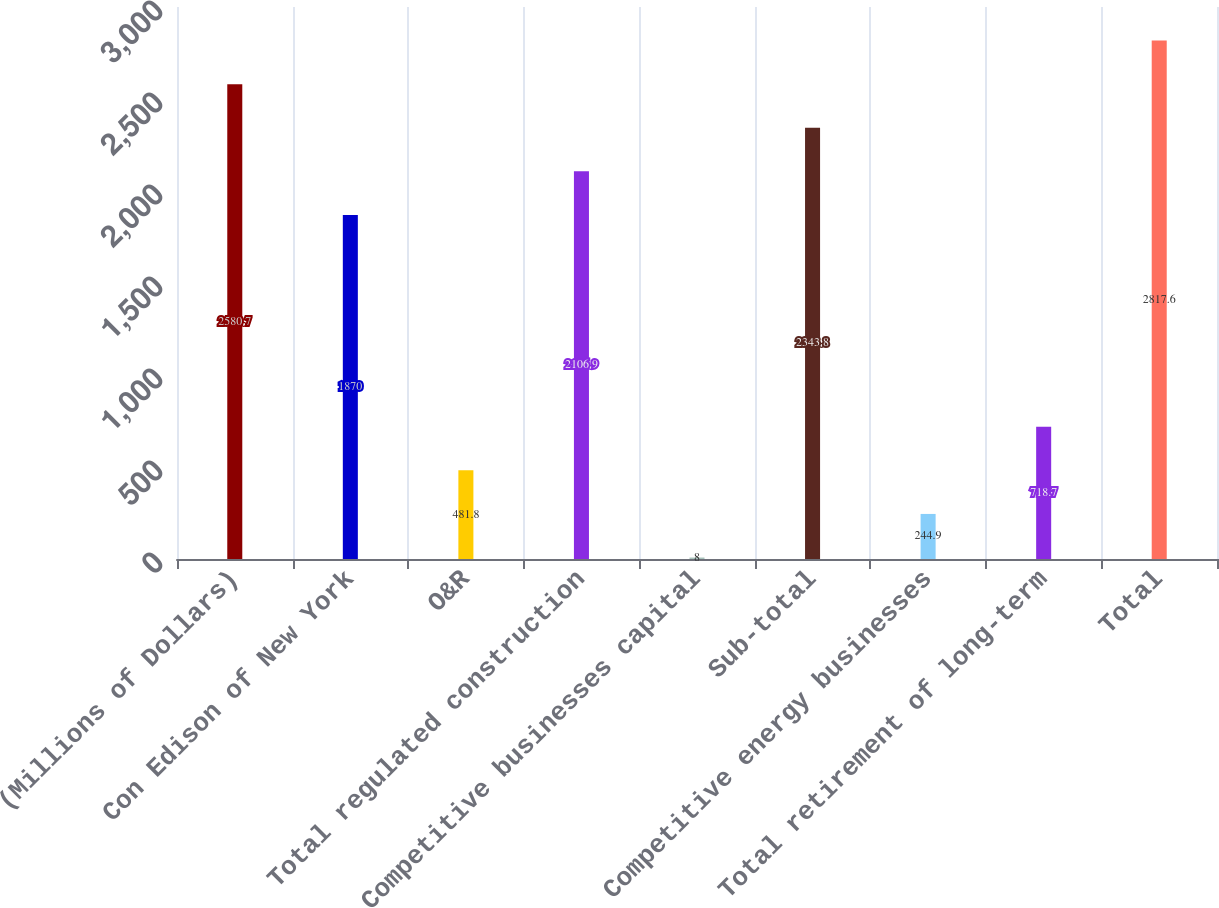Convert chart. <chart><loc_0><loc_0><loc_500><loc_500><bar_chart><fcel>(Millions of Dollars)<fcel>Con Edison of New York<fcel>O&R<fcel>Total regulated construction<fcel>Competitive businesses capital<fcel>Sub-total<fcel>Competitive energy businesses<fcel>Total retirement of long-term<fcel>Total<nl><fcel>2580.7<fcel>1870<fcel>481.8<fcel>2106.9<fcel>8<fcel>2343.8<fcel>244.9<fcel>718.7<fcel>2817.6<nl></chart> 